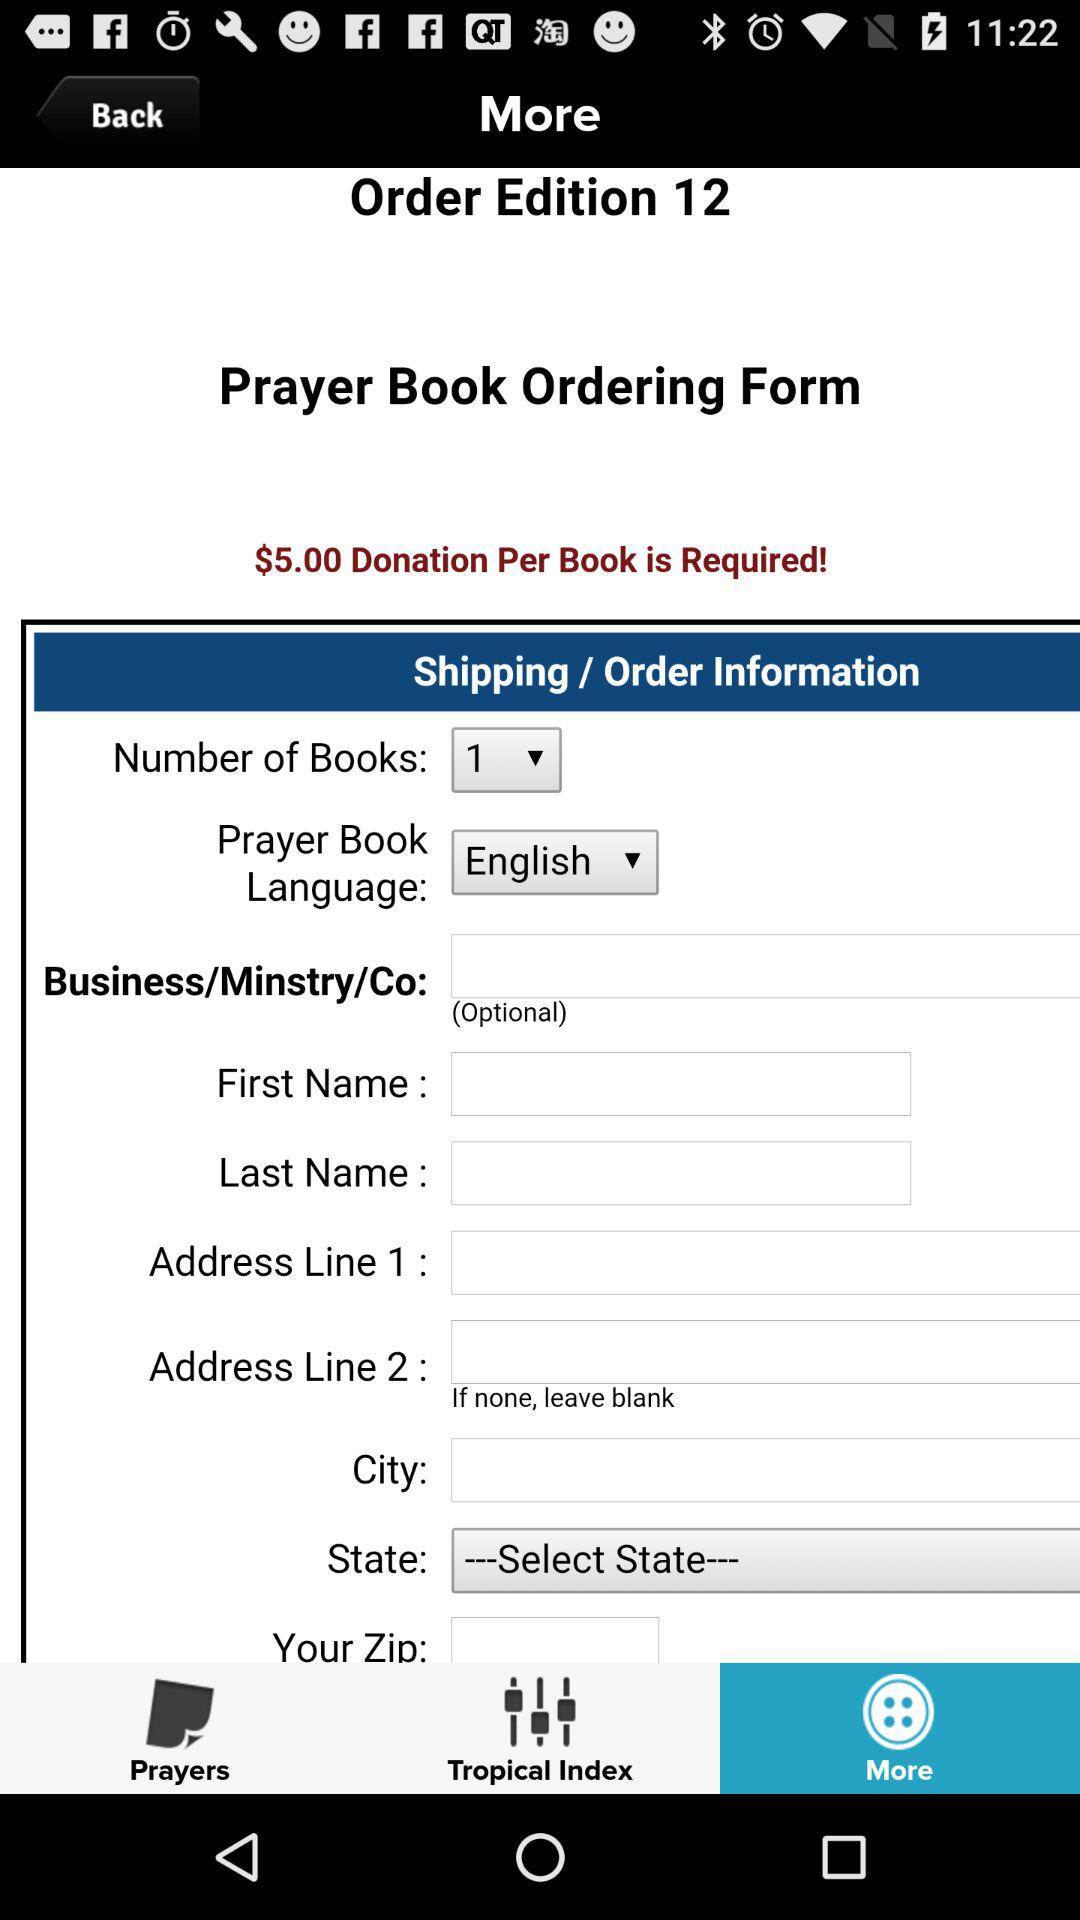What language is selected? The selected language is English. 